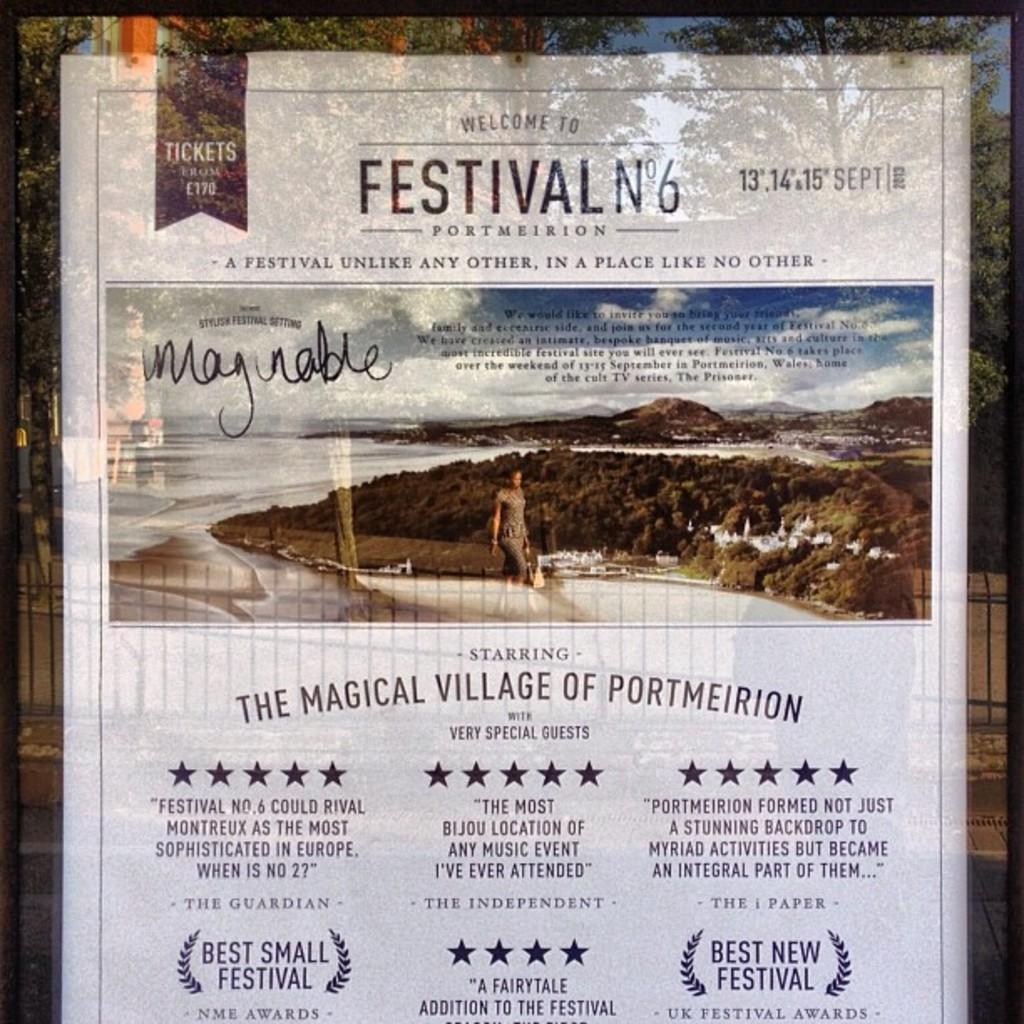<image>
Provide a brief description of the given image. A white welcome poster of Festival N°6 show. 